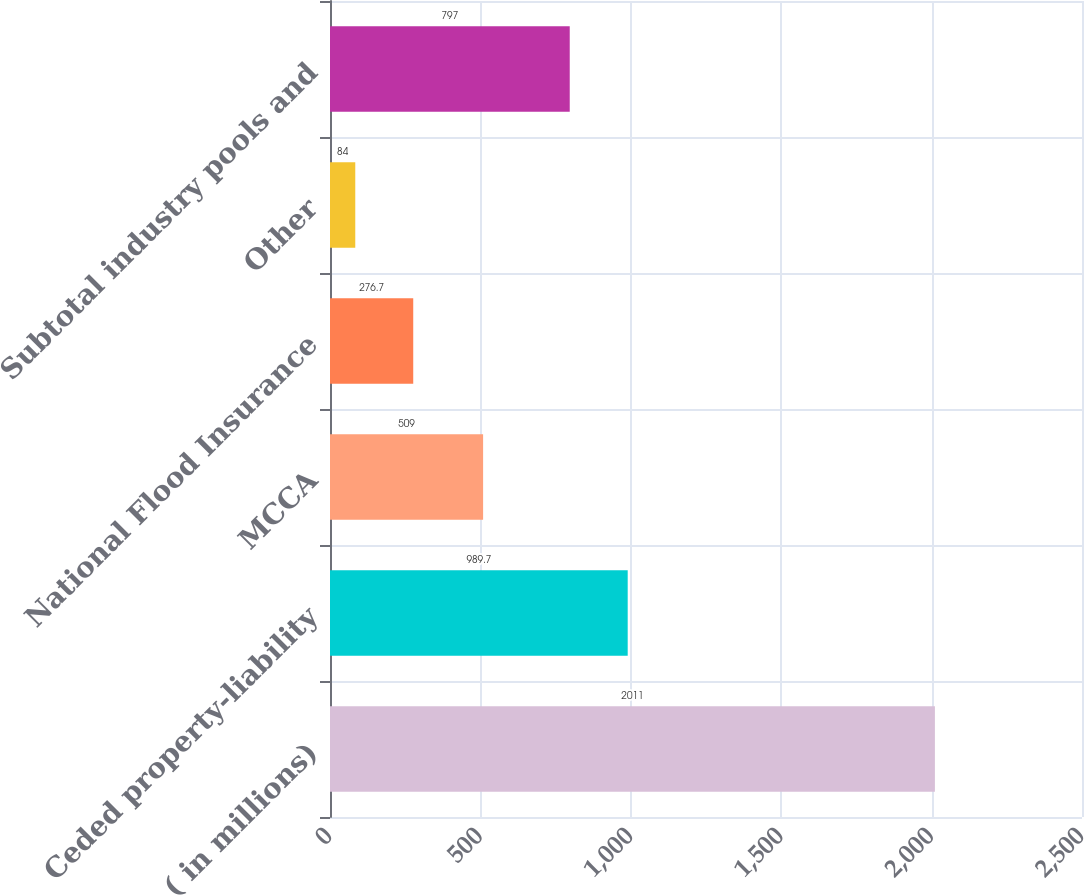Convert chart. <chart><loc_0><loc_0><loc_500><loc_500><bar_chart><fcel>( in millions)<fcel>Ceded property-liability<fcel>MCCA<fcel>National Flood Insurance<fcel>Other<fcel>Subtotal industry pools and<nl><fcel>2011<fcel>989.7<fcel>509<fcel>276.7<fcel>84<fcel>797<nl></chart> 